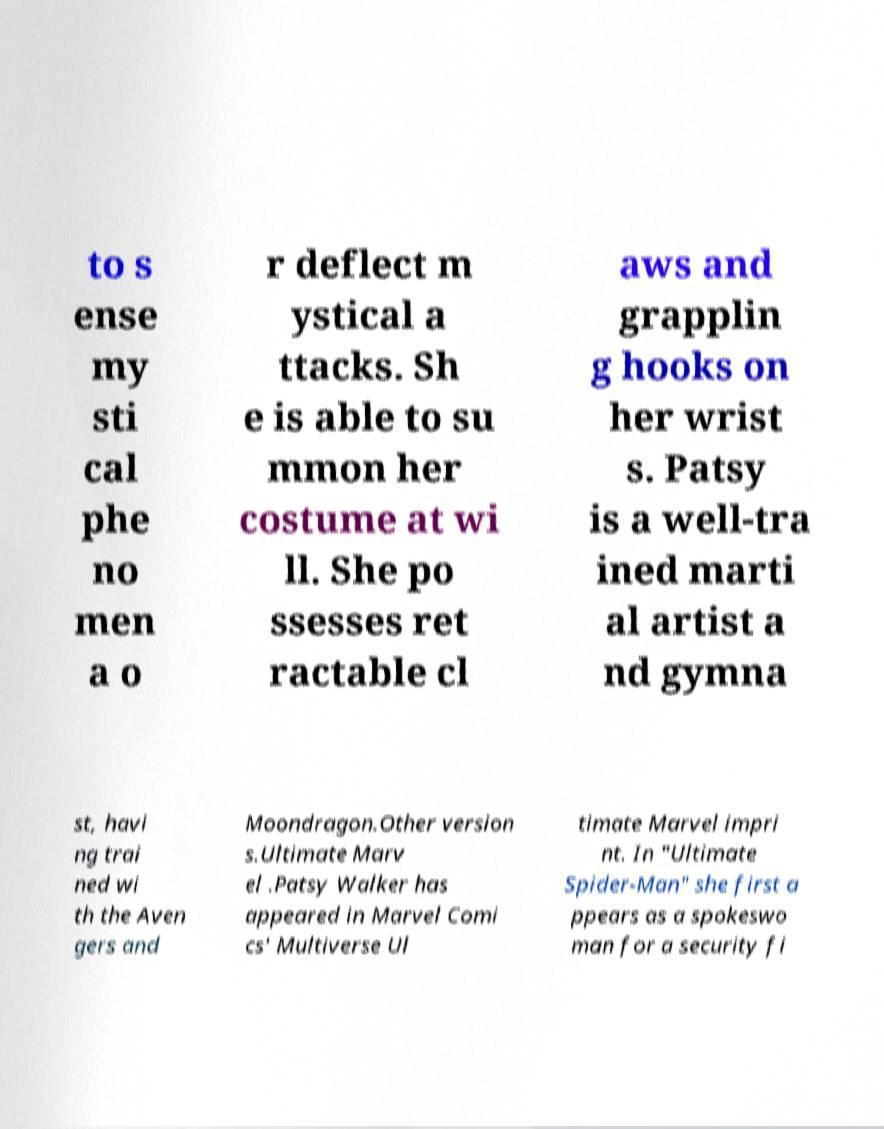There's text embedded in this image that I need extracted. Can you transcribe it verbatim? to s ense my sti cal phe no men a o r deflect m ystical a ttacks. Sh e is able to su mmon her costume at wi ll. She po ssesses ret ractable cl aws and grapplin g hooks on her wrist s. Patsy is a well-tra ined marti al artist a nd gymna st, havi ng trai ned wi th the Aven gers and Moondragon.Other version s.Ultimate Marv el .Patsy Walker has appeared in Marvel Comi cs' Multiverse Ul timate Marvel impri nt. In "Ultimate Spider-Man" she first a ppears as a spokeswo man for a security fi 